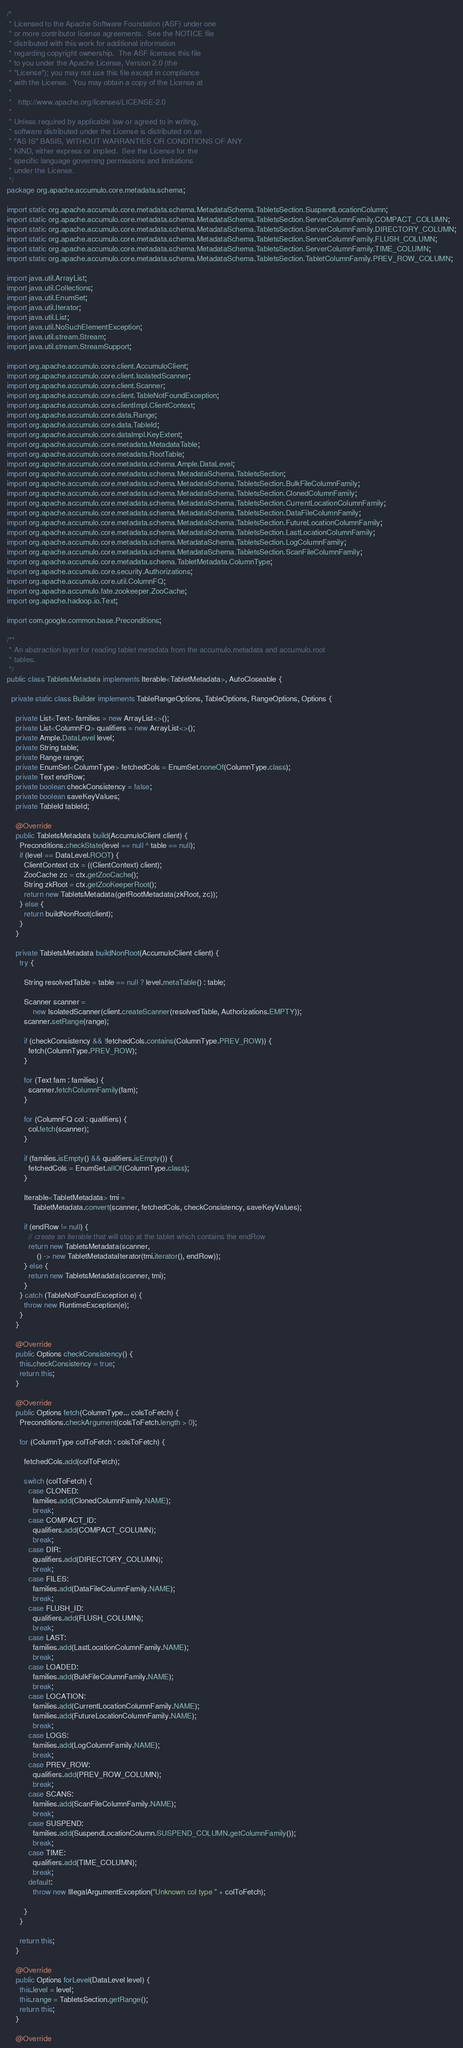<code> <loc_0><loc_0><loc_500><loc_500><_Java_>/*
 * Licensed to the Apache Software Foundation (ASF) under one
 * or more contributor license agreements.  See the NOTICE file
 * distributed with this work for additional information
 * regarding copyright ownership.  The ASF licenses this file
 * to you under the Apache License, Version 2.0 (the
 * "License"); you may not use this file except in compliance
 * with the License.  You may obtain a copy of the License at
 *
 *   http://www.apache.org/licenses/LICENSE-2.0
 *
 * Unless required by applicable law or agreed to in writing,
 * software distributed under the License is distributed on an
 * "AS IS" BASIS, WITHOUT WARRANTIES OR CONDITIONS OF ANY
 * KIND, either express or implied.  See the License for the
 * specific language governing permissions and limitations
 * under the License.
 */
package org.apache.accumulo.core.metadata.schema;

import static org.apache.accumulo.core.metadata.schema.MetadataSchema.TabletsSection.SuspendLocationColumn;
import static org.apache.accumulo.core.metadata.schema.MetadataSchema.TabletsSection.ServerColumnFamily.COMPACT_COLUMN;
import static org.apache.accumulo.core.metadata.schema.MetadataSchema.TabletsSection.ServerColumnFamily.DIRECTORY_COLUMN;
import static org.apache.accumulo.core.metadata.schema.MetadataSchema.TabletsSection.ServerColumnFamily.FLUSH_COLUMN;
import static org.apache.accumulo.core.metadata.schema.MetadataSchema.TabletsSection.ServerColumnFamily.TIME_COLUMN;
import static org.apache.accumulo.core.metadata.schema.MetadataSchema.TabletsSection.TabletColumnFamily.PREV_ROW_COLUMN;

import java.util.ArrayList;
import java.util.Collections;
import java.util.EnumSet;
import java.util.Iterator;
import java.util.List;
import java.util.NoSuchElementException;
import java.util.stream.Stream;
import java.util.stream.StreamSupport;

import org.apache.accumulo.core.client.AccumuloClient;
import org.apache.accumulo.core.client.IsolatedScanner;
import org.apache.accumulo.core.client.Scanner;
import org.apache.accumulo.core.client.TableNotFoundException;
import org.apache.accumulo.core.clientImpl.ClientContext;
import org.apache.accumulo.core.data.Range;
import org.apache.accumulo.core.data.TableId;
import org.apache.accumulo.core.dataImpl.KeyExtent;
import org.apache.accumulo.core.metadata.MetadataTable;
import org.apache.accumulo.core.metadata.RootTable;
import org.apache.accumulo.core.metadata.schema.Ample.DataLevel;
import org.apache.accumulo.core.metadata.schema.MetadataSchema.TabletsSection;
import org.apache.accumulo.core.metadata.schema.MetadataSchema.TabletsSection.BulkFileColumnFamily;
import org.apache.accumulo.core.metadata.schema.MetadataSchema.TabletsSection.ClonedColumnFamily;
import org.apache.accumulo.core.metadata.schema.MetadataSchema.TabletsSection.CurrentLocationColumnFamily;
import org.apache.accumulo.core.metadata.schema.MetadataSchema.TabletsSection.DataFileColumnFamily;
import org.apache.accumulo.core.metadata.schema.MetadataSchema.TabletsSection.FutureLocationColumnFamily;
import org.apache.accumulo.core.metadata.schema.MetadataSchema.TabletsSection.LastLocationColumnFamily;
import org.apache.accumulo.core.metadata.schema.MetadataSchema.TabletsSection.LogColumnFamily;
import org.apache.accumulo.core.metadata.schema.MetadataSchema.TabletsSection.ScanFileColumnFamily;
import org.apache.accumulo.core.metadata.schema.TabletMetadata.ColumnType;
import org.apache.accumulo.core.security.Authorizations;
import org.apache.accumulo.core.util.ColumnFQ;
import org.apache.accumulo.fate.zookeeper.ZooCache;
import org.apache.hadoop.io.Text;

import com.google.common.base.Preconditions;

/**
 * An abstraction layer for reading tablet metadata from the accumulo.metadata and accumulo.root
 * tables.
 */
public class TabletsMetadata implements Iterable<TabletMetadata>, AutoCloseable {

  private static class Builder implements TableRangeOptions, TableOptions, RangeOptions, Options {

    private List<Text> families = new ArrayList<>();
    private List<ColumnFQ> qualifiers = new ArrayList<>();
    private Ample.DataLevel level;
    private String table;
    private Range range;
    private EnumSet<ColumnType> fetchedCols = EnumSet.noneOf(ColumnType.class);
    private Text endRow;
    private boolean checkConsistency = false;
    private boolean saveKeyValues;
    private TableId tableId;

    @Override
    public TabletsMetadata build(AccumuloClient client) {
      Preconditions.checkState(level == null ^ table == null);
      if (level == DataLevel.ROOT) {
        ClientContext ctx = ((ClientContext) client);
        ZooCache zc = ctx.getZooCache();
        String zkRoot = ctx.getZooKeeperRoot();
        return new TabletsMetadata(getRootMetadata(zkRoot, zc));
      } else {
        return buildNonRoot(client);
      }
    }

    private TabletsMetadata buildNonRoot(AccumuloClient client) {
      try {

        String resolvedTable = table == null ? level.metaTable() : table;

        Scanner scanner =
            new IsolatedScanner(client.createScanner(resolvedTable, Authorizations.EMPTY));
        scanner.setRange(range);

        if (checkConsistency && !fetchedCols.contains(ColumnType.PREV_ROW)) {
          fetch(ColumnType.PREV_ROW);
        }

        for (Text fam : families) {
          scanner.fetchColumnFamily(fam);
        }

        for (ColumnFQ col : qualifiers) {
          col.fetch(scanner);
        }

        if (families.isEmpty() && qualifiers.isEmpty()) {
          fetchedCols = EnumSet.allOf(ColumnType.class);
        }

        Iterable<TabletMetadata> tmi =
            TabletMetadata.convert(scanner, fetchedCols, checkConsistency, saveKeyValues);

        if (endRow != null) {
          // create an iterable that will stop at the tablet which contains the endRow
          return new TabletsMetadata(scanner,
              () -> new TabletMetadataIterator(tmi.iterator(), endRow));
        } else {
          return new TabletsMetadata(scanner, tmi);
        }
      } catch (TableNotFoundException e) {
        throw new RuntimeException(e);
      }
    }

    @Override
    public Options checkConsistency() {
      this.checkConsistency = true;
      return this;
    }

    @Override
    public Options fetch(ColumnType... colsToFetch) {
      Preconditions.checkArgument(colsToFetch.length > 0);

      for (ColumnType colToFetch : colsToFetch) {

        fetchedCols.add(colToFetch);

        switch (colToFetch) {
          case CLONED:
            families.add(ClonedColumnFamily.NAME);
            break;
          case COMPACT_ID:
            qualifiers.add(COMPACT_COLUMN);
            break;
          case DIR:
            qualifiers.add(DIRECTORY_COLUMN);
            break;
          case FILES:
            families.add(DataFileColumnFamily.NAME);
            break;
          case FLUSH_ID:
            qualifiers.add(FLUSH_COLUMN);
            break;
          case LAST:
            families.add(LastLocationColumnFamily.NAME);
            break;
          case LOADED:
            families.add(BulkFileColumnFamily.NAME);
            break;
          case LOCATION:
            families.add(CurrentLocationColumnFamily.NAME);
            families.add(FutureLocationColumnFamily.NAME);
            break;
          case LOGS:
            families.add(LogColumnFamily.NAME);
            break;
          case PREV_ROW:
            qualifiers.add(PREV_ROW_COLUMN);
            break;
          case SCANS:
            families.add(ScanFileColumnFamily.NAME);
            break;
          case SUSPEND:
            families.add(SuspendLocationColumn.SUSPEND_COLUMN.getColumnFamily());
            break;
          case TIME:
            qualifiers.add(TIME_COLUMN);
            break;
          default:
            throw new IllegalArgumentException("Unknown col type " + colToFetch);

        }
      }

      return this;
    }

    @Override
    public Options forLevel(DataLevel level) {
      this.level = level;
      this.range = TabletsSection.getRange();
      return this;
    }

    @Override</code> 